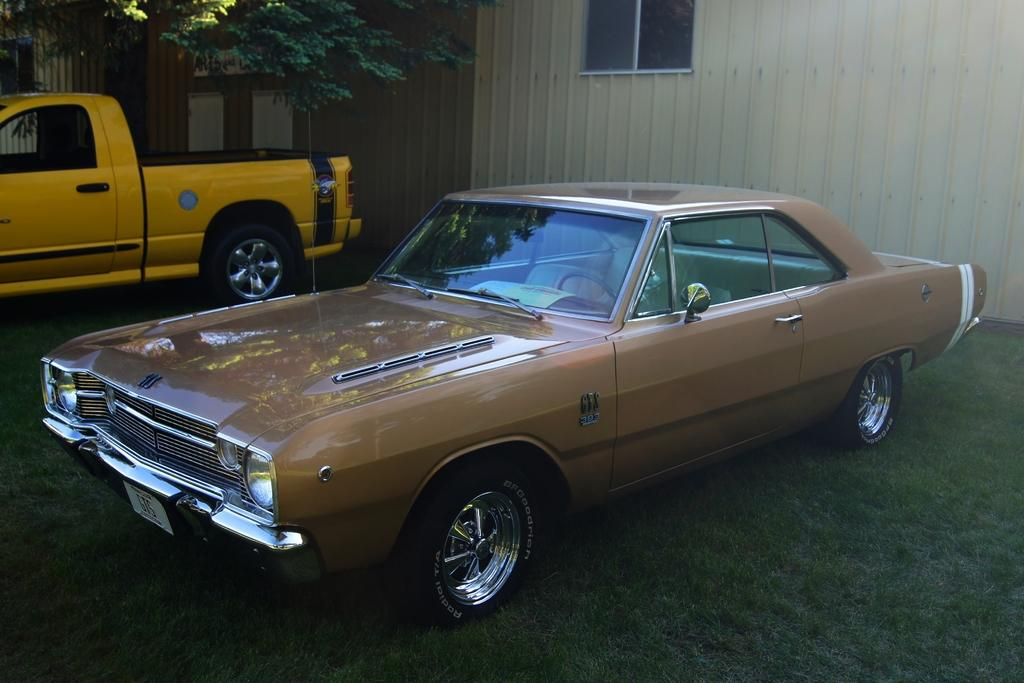What is the main subject in the foreground of the image? There is a car in the foreground of the image, on the grass. What other vehicle can be seen in the image? There is a yellow van in the background of the image. What structures are visible in the background of the image? There is a wall and a window in the background of the image. What type of vegetation is present in the background of the image? There is a tree in the background of the image. Can you see a twig being used as a tool in the image? There is no twig visible in the image. 